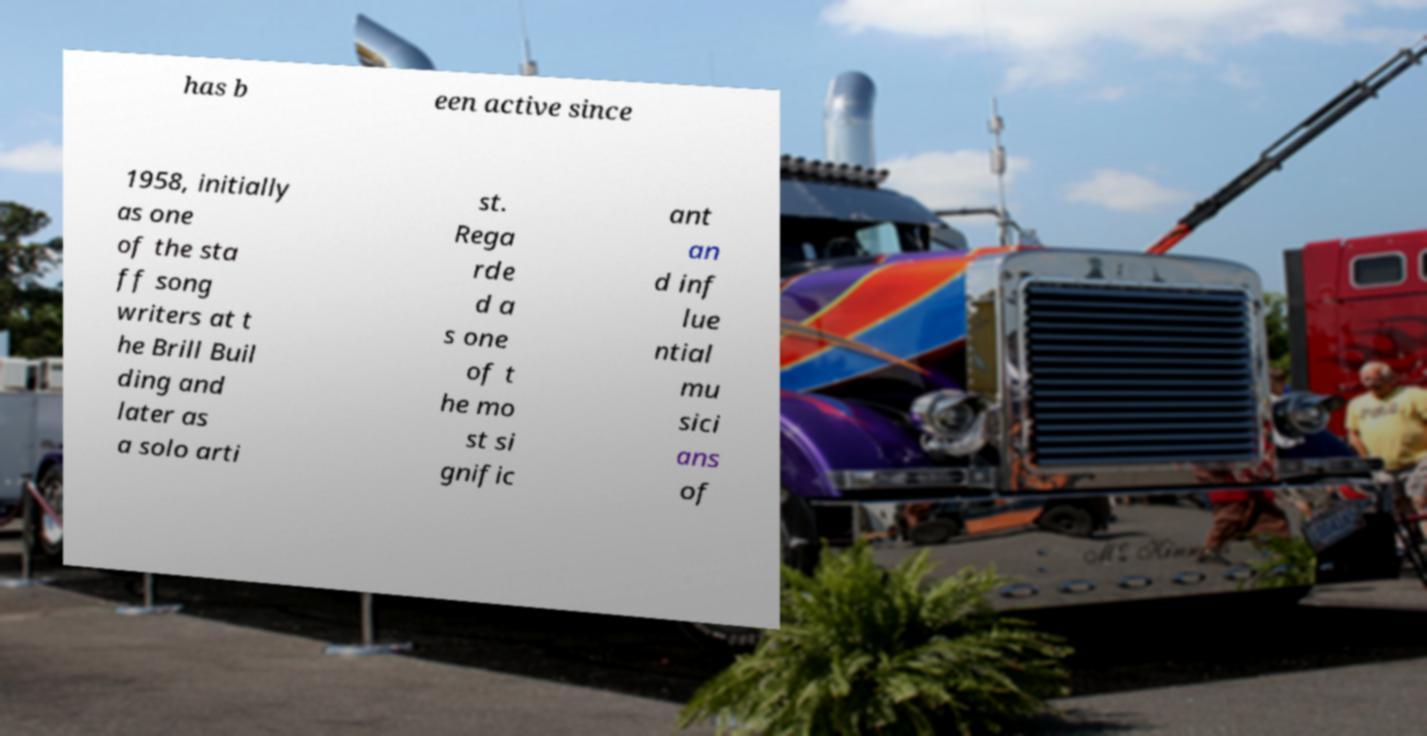Please read and relay the text visible in this image. What does it say? has b een active since 1958, initially as one of the sta ff song writers at t he Brill Buil ding and later as a solo arti st. Rega rde d a s one of t he mo st si gnific ant an d inf lue ntial mu sici ans of 